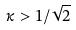<formula> <loc_0><loc_0><loc_500><loc_500>\kappa > 1 / \sqrt { 2 }</formula> 